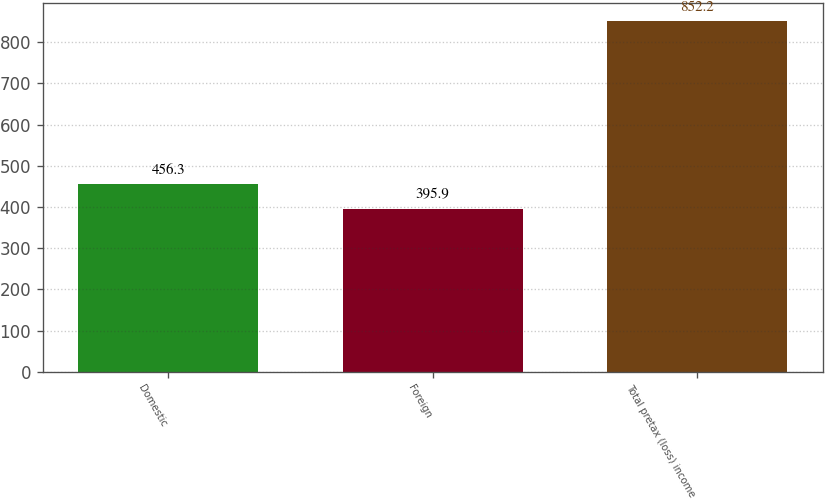Convert chart to OTSL. <chart><loc_0><loc_0><loc_500><loc_500><bar_chart><fcel>Domestic<fcel>Foreign<fcel>Total pretax (loss) income<nl><fcel>456.3<fcel>395.9<fcel>852.2<nl></chart> 